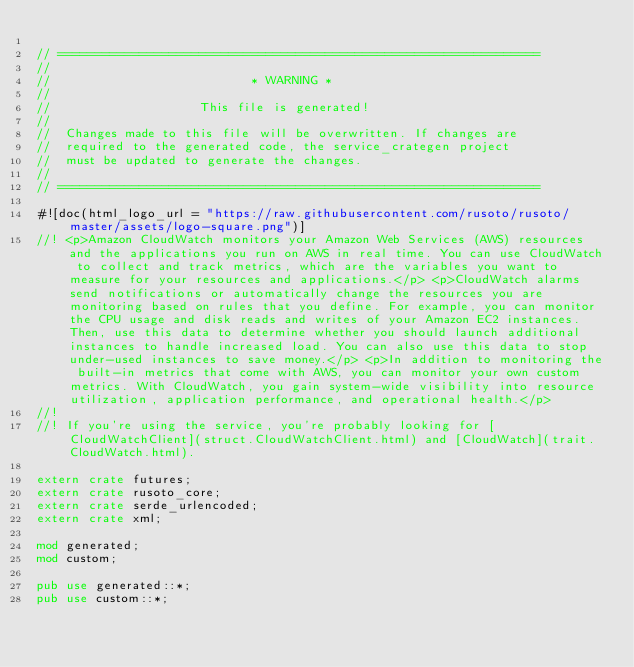<code> <loc_0><loc_0><loc_500><loc_500><_Rust_>
// =================================================================
//
//                           * WARNING *
//
//                    This file is generated!
//
//  Changes made to this file will be overwritten. If changes are
//  required to the generated code, the service_crategen project
//  must be updated to generate the changes.
//
// =================================================================

#![doc(html_logo_url = "https://raw.githubusercontent.com/rusoto/rusoto/master/assets/logo-square.png")]
//! <p>Amazon CloudWatch monitors your Amazon Web Services (AWS) resources and the applications you run on AWS in real time. You can use CloudWatch to collect and track metrics, which are the variables you want to measure for your resources and applications.</p> <p>CloudWatch alarms send notifications or automatically change the resources you are monitoring based on rules that you define. For example, you can monitor the CPU usage and disk reads and writes of your Amazon EC2 instances. Then, use this data to determine whether you should launch additional instances to handle increased load. You can also use this data to stop under-used instances to save money.</p> <p>In addition to monitoring the built-in metrics that come with AWS, you can monitor your own custom metrics. With CloudWatch, you gain system-wide visibility into resource utilization, application performance, and operational health.</p>
//!
//! If you're using the service, you're probably looking for [CloudWatchClient](struct.CloudWatchClient.html) and [CloudWatch](trait.CloudWatch.html).

extern crate futures;
extern crate rusoto_core;
extern crate serde_urlencoded;
extern crate xml;

mod generated;
mod custom;

pub use generated::*;
pub use custom::*;
            
</code> 